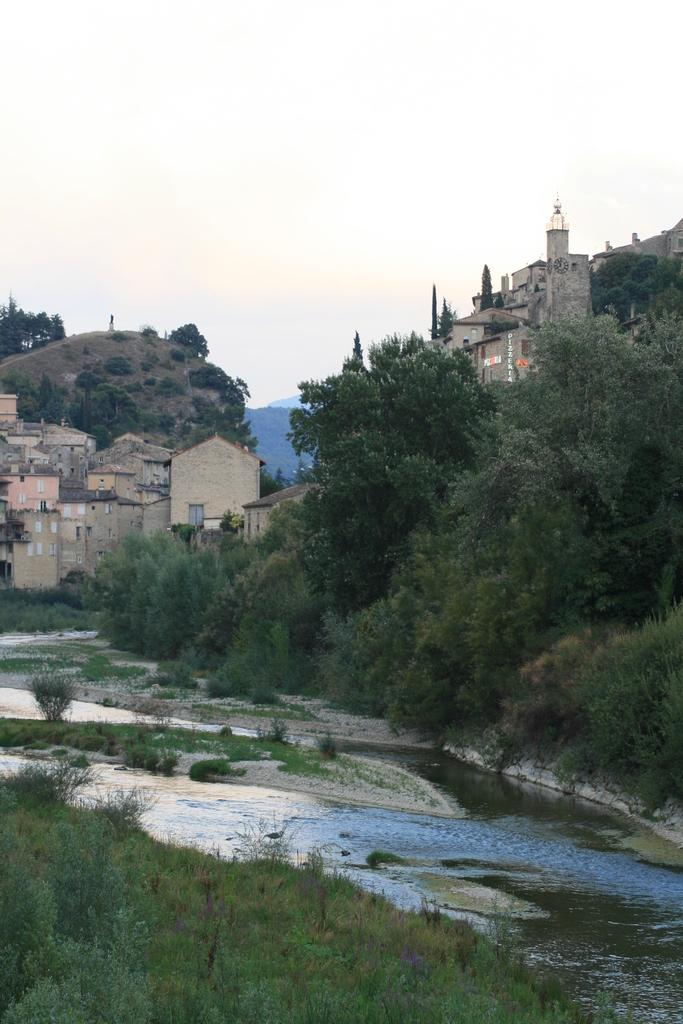What can be seen in the sky in the image? The sky is visible in the image. What type of structures are present in the image? There are buildings in the image. What type of natural features can be seen in the image? Hills, a river, and trees are present in the image. What type of vegetation is visible in the image? Shrubs, grass, and plants are visible in the image. What is the ground like in the image? The ground is visible in the image. How many balls are visible in the image? There are no balls present in the image. Can you describe the kitty playing with the bikes in the image? There is no kitty or bikes present in the image. 